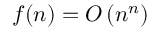Convert formula to latex. <formula><loc_0><loc_0><loc_500><loc_500>f ( n ) = O \left ( n ^ { n } \right )</formula> 